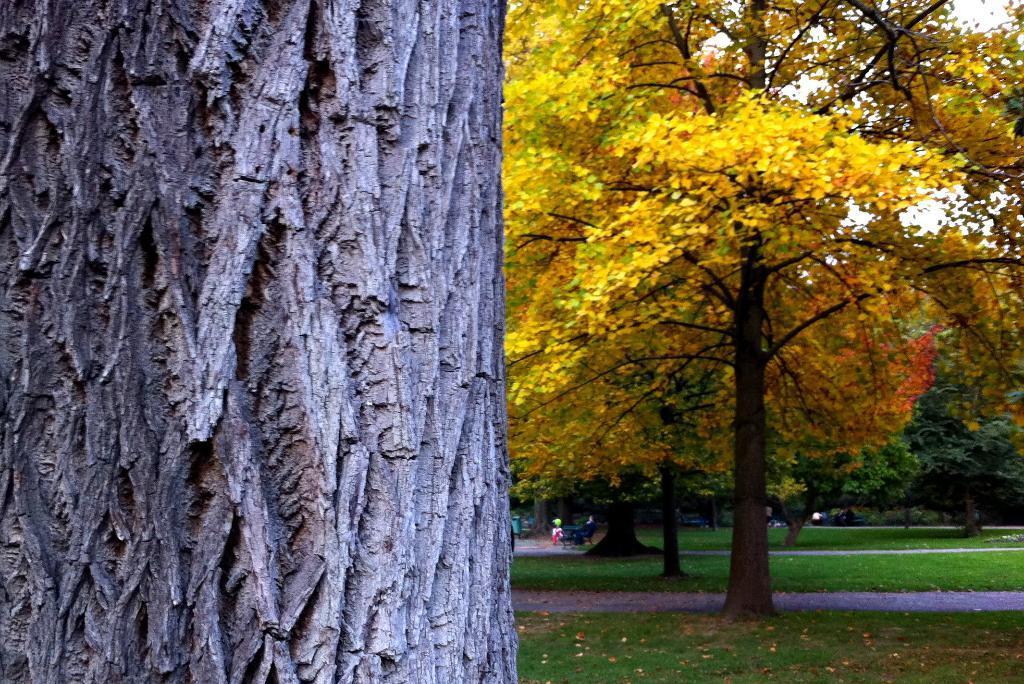How would you summarize this image in a sentence or two? In this image I can see many trees. And these trees are in yellow, orange and green color. And I can see the grass on the ground. 